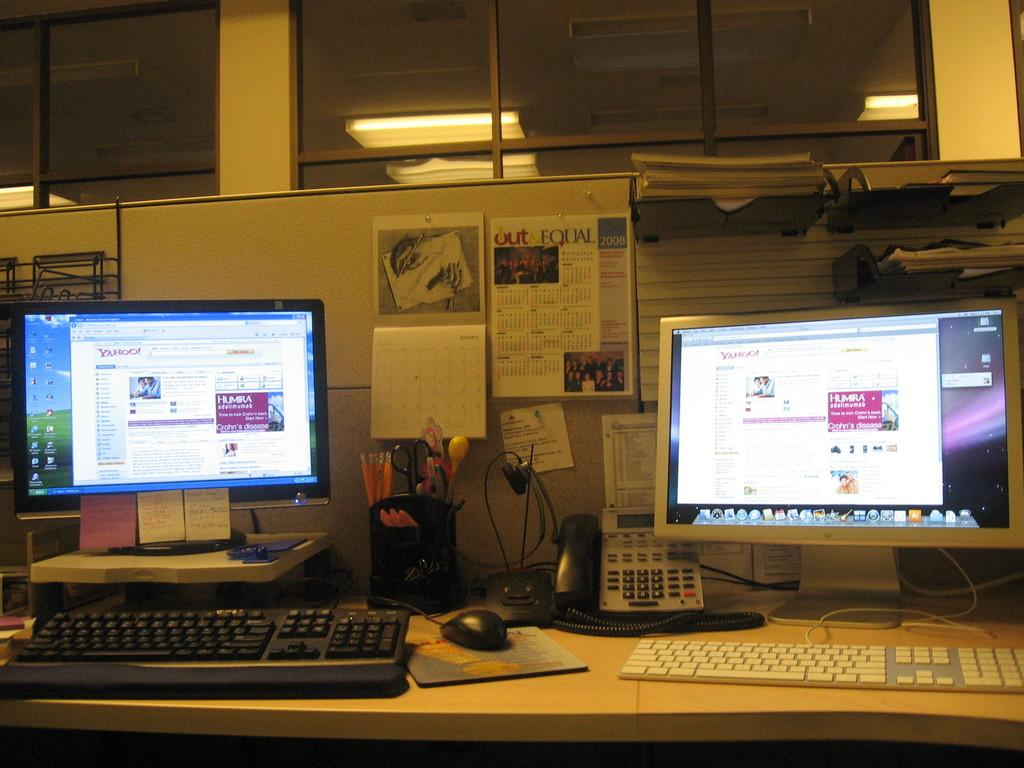<image>
Provide a brief description of the given image. Two computer screens can be seen and one of them has a Yahoo page opened. 